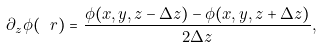Convert formula to latex. <formula><loc_0><loc_0><loc_500><loc_500>\partial _ { z } \phi ( \ r ) = \frac { \phi ( x , y , z - \Delta z ) - \phi ( x , y , z + \Delta z ) } { 2 \Delta z } ,</formula> 